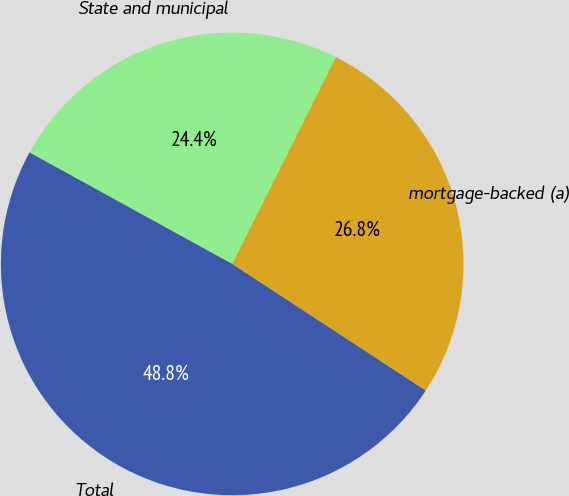Convert chart to OTSL. <chart><loc_0><loc_0><loc_500><loc_500><pie_chart><fcel>State and municipal<fcel>mortgage-backed (a)<fcel>Total<nl><fcel>24.39%<fcel>26.83%<fcel>48.78%<nl></chart> 